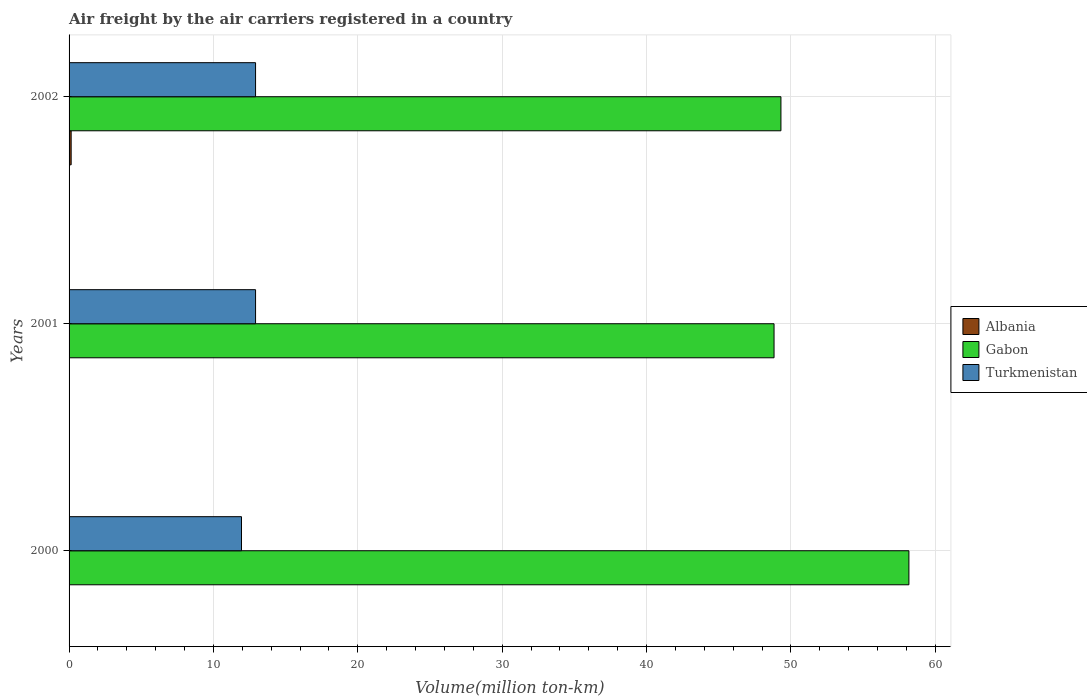Are the number of bars on each tick of the Y-axis equal?
Keep it short and to the point. Yes. How many bars are there on the 3rd tick from the bottom?
Give a very brief answer. 3. What is the label of the 1st group of bars from the top?
Ensure brevity in your answer.  2002. In how many cases, is the number of bars for a given year not equal to the number of legend labels?
Make the answer very short. 0. What is the volume of the air carriers in Albania in 2001?
Offer a very short reply. 0. Across all years, what is the maximum volume of the air carriers in Albania?
Provide a short and direct response. 0.14. Across all years, what is the minimum volume of the air carriers in Albania?
Provide a succinct answer. 0. In which year was the volume of the air carriers in Gabon maximum?
Provide a short and direct response. 2000. In which year was the volume of the air carriers in Gabon minimum?
Offer a very short reply. 2001. What is the total volume of the air carriers in Turkmenistan in the graph?
Provide a short and direct response. 37.78. What is the difference between the volume of the air carriers in Turkmenistan in 2000 and that in 2002?
Provide a succinct answer. -0.97. What is the difference between the volume of the air carriers in Turkmenistan in 2000 and the volume of the air carriers in Albania in 2001?
Your response must be concise. 11.94. What is the average volume of the air carriers in Turkmenistan per year?
Provide a short and direct response. 12.59. In the year 2002, what is the difference between the volume of the air carriers in Gabon and volume of the air carriers in Albania?
Your answer should be compact. 49.17. In how many years, is the volume of the air carriers in Gabon greater than 10 million ton-km?
Offer a terse response. 3. What is the ratio of the volume of the air carriers in Turkmenistan in 2000 to that in 2002?
Keep it short and to the point. 0.92. Is the difference between the volume of the air carriers in Gabon in 2000 and 2002 greater than the difference between the volume of the air carriers in Albania in 2000 and 2002?
Your response must be concise. Yes. What is the difference between the highest and the second highest volume of the air carriers in Gabon?
Offer a terse response. 8.86. What is the difference between the highest and the lowest volume of the air carriers in Albania?
Your response must be concise. 0.14. In how many years, is the volume of the air carriers in Gabon greater than the average volume of the air carriers in Gabon taken over all years?
Your answer should be compact. 1. What does the 1st bar from the top in 2002 represents?
Your response must be concise. Turkmenistan. What does the 3rd bar from the bottom in 2000 represents?
Your answer should be compact. Turkmenistan. Is it the case that in every year, the sum of the volume of the air carriers in Gabon and volume of the air carriers in Turkmenistan is greater than the volume of the air carriers in Albania?
Provide a short and direct response. Yes. Are all the bars in the graph horizontal?
Ensure brevity in your answer.  Yes. What is the difference between two consecutive major ticks on the X-axis?
Offer a very short reply. 10. Are the values on the major ticks of X-axis written in scientific E-notation?
Your answer should be compact. No. Does the graph contain any zero values?
Your answer should be compact. No. Does the graph contain grids?
Provide a succinct answer. Yes. Where does the legend appear in the graph?
Provide a succinct answer. Center right. How many legend labels are there?
Provide a short and direct response. 3. How are the legend labels stacked?
Give a very brief answer. Vertical. What is the title of the graph?
Offer a terse response. Air freight by the air carriers registered in a country. What is the label or title of the X-axis?
Offer a terse response. Volume(million ton-km). What is the label or title of the Y-axis?
Your response must be concise. Years. What is the Volume(million ton-km) in Albania in 2000?
Ensure brevity in your answer.  0. What is the Volume(million ton-km) in Gabon in 2000?
Offer a terse response. 58.17. What is the Volume(million ton-km) in Turkmenistan in 2000?
Your response must be concise. 11.94. What is the Volume(million ton-km) in Albania in 2001?
Keep it short and to the point. 0. What is the Volume(million ton-km) in Gabon in 2001?
Offer a very short reply. 48.83. What is the Volume(million ton-km) of Turkmenistan in 2001?
Your answer should be very brief. 12.92. What is the Volume(million ton-km) in Albania in 2002?
Provide a short and direct response. 0.14. What is the Volume(million ton-km) in Gabon in 2002?
Your response must be concise. 49.31. What is the Volume(million ton-km) of Turkmenistan in 2002?
Offer a very short reply. 12.92. Across all years, what is the maximum Volume(million ton-km) of Albania?
Offer a very short reply. 0.14. Across all years, what is the maximum Volume(million ton-km) of Gabon?
Give a very brief answer. 58.17. Across all years, what is the maximum Volume(million ton-km) of Turkmenistan?
Provide a short and direct response. 12.92. Across all years, what is the minimum Volume(million ton-km) in Albania?
Your response must be concise. 0. Across all years, what is the minimum Volume(million ton-km) of Gabon?
Offer a terse response. 48.83. Across all years, what is the minimum Volume(million ton-km) of Turkmenistan?
Your response must be concise. 11.94. What is the total Volume(million ton-km) in Gabon in the graph?
Offer a terse response. 156.32. What is the total Volume(million ton-km) of Turkmenistan in the graph?
Provide a short and direct response. 37.78. What is the difference between the Volume(million ton-km) in Albania in 2000 and that in 2001?
Offer a very short reply. 0. What is the difference between the Volume(million ton-km) in Gabon in 2000 and that in 2001?
Your answer should be very brief. 9.34. What is the difference between the Volume(million ton-km) of Turkmenistan in 2000 and that in 2001?
Ensure brevity in your answer.  -0.97. What is the difference between the Volume(million ton-km) of Albania in 2000 and that in 2002?
Provide a short and direct response. -0.14. What is the difference between the Volume(million ton-km) in Gabon in 2000 and that in 2002?
Your response must be concise. 8.86. What is the difference between the Volume(million ton-km) in Turkmenistan in 2000 and that in 2002?
Your response must be concise. -0.97. What is the difference between the Volume(million ton-km) in Albania in 2001 and that in 2002?
Provide a succinct answer. -0.14. What is the difference between the Volume(million ton-km) in Gabon in 2001 and that in 2002?
Your answer should be very brief. -0.48. What is the difference between the Volume(million ton-km) in Turkmenistan in 2001 and that in 2002?
Ensure brevity in your answer.  0. What is the difference between the Volume(million ton-km) of Albania in 2000 and the Volume(million ton-km) of Gabon in 2001?
Ensure brevity in your answer.  -48.83. What is the difference between the Volume(million ton-km) in Albania in 2000 and the Volume(million ton-km) in Turkmenistan in 2001?
Provide a succinct answer. -12.91. What is the difference between the Volume(million ton-km) of Gabon in 2000 and the Volume(million ton-km) of Turkmenistan in 2001?
Your answer should be very brief. 45.26. What is the difference between the Volume(million ton-km) of Albania in 2000 and the Volume(million ton-km) of Gabon in 2002?
Provide a short and direct response. -49.31. What is the difference between the Volume(million ton-km) in Albania in 2000 and the Volume(million ton-km) in Turkmenistan in 2002?
Your response must be concise. -12.91. What is the difference between the Volume(million ton-km) in Gabon in 2000 and the Volume(million ton-km) in Turkmenistan in 2002?
Make the answer very short. 45.26. What is the difference between the Volume(million ton-km) in Albania in 2001 and the Volume(million ton-km) in Gabon in 2002?
Provide a succinct answer. -49.31. What is the difference between the Volume(million ton-km) in Albania in 2001 and the Volume(million ton-km) in Turkmenistan in 2002?
Offer a terse response. -12.91. What is the difference between the Volume(million ton-km) of Gabon in 2001 and the Volume(million ton-km) of Turkmenistan in 2002?
Offer a terse response. 35.91. What is the average Volume(million ton-km) of Albania per year?
Your response must be concise. 0.05. What is the average Volume(million ton-km) of Gabon per year?
Ensure brevity in your answer.  52.11. What is the average Volume(million ton-km) in Turkmenistan per year?
Give a very brief answer. 12.59. In the year 2000, what is the difference between the Volume(million ton-km) of Albania and Volume(million ton-km) of Gabon?
Provide a succinct answer. -58.17. In the year 2000, what is the difference between the Volume(million ton-km) of Albania and Volume(million ton-km) of Turkmenistan?
Provide a succinct answer. -11.94. In the year 2000, what is the difference between the Volume(million ton-km) of Gabon and Volume(million ton-km) of Turkmenistan?
Provide a succinct answer. 46.23. In the year 2001, what is the difference between the Volume(million ton-km) in Albania and Volume(million ton-km) in Gabon?
Your response must be concise. -48.83. In the year 2001, what is the difference between the Volume(million ton-km) in Albania and Volume(million ton-km) in Turkmenistan?
Provide a short and direct response. -12.91. In the year 2001, what is the difference between the Volume(million ton-km) of Gabon and Volume(million ton-km) of Turkmenistan?
Provide a succinct answer. 35.91. In the year 2002, what is the difference between the Volume(million ton-km) in Albania and Volume(million ton-km) in Gabon?
Ensure brevity in your answer.  -49.17. In the year 2002, what is the difference between the Volume(million ton-km) of Albania and Volume(million ton-km) of Turkmenistan?
Provide a short and direct response. -12.77. In the year 2002, what is the difference between the Volume(million ton-km) in Gabon and Volume(million ton-km) in Turkmenistan?
Keep it short and to the point. 36.39. What is the ratio of the Volume(million ton-km) of Albania in 2000 to that in 2001?
Provide a succinct answer. 1. What is the ratio of the Volume(million ton-km) of Gabon in 2000 to that in 2001?
Keep it short and to the point. 1.19. What is the ratio of the Volume(million ton-km) in Turkmenistan in 2000 to that in 2001?
Make the answer very short. 0.92. What is the ratio of the Volume(million ton-km) in Albania in 2000 to that in 2002?
Ensure brevity in your answer.  0.02. What is the ratio of the Volume(million ton-km) in Gabon in 2000 to that in 2002?
Make the answer very short. 1.18. What is the ratio of the Volume(million ton-km) of Turkmenistan in 2000 to that in 2002?
Ensure brevity in your answer.  0.92. What is the ratio of the Volume(million ton-km) in Albania in 2001 to that in 2002?
Keep it short and to the point. 0.02. What is the ratio of the Volume(million ton-km) of Gabon in 2001 to that in 2002?
Ensure brevity in your answer.  0.99. What is the difference between the highest and the second highest Volume(million ton-km) of Albania?
Your answer should be very brief. 0.14. What is the difference between the highest and the second highest Volume(million ton-km) of Gabon?
Your answer should be compact. 8.86. What is the difference between the highest and the lowest Volume(million ton-km) of Albania?
Make the answer very short. 0.14. What is the difference between the highest and the lowest Volume(million ton-km) of Gabon?
Provide a short and direct response. 9.34. What is the difference between the highest and the lowest Volume(million ton-km) in Turkmenistan?
Make the answer very short. 0.97. 